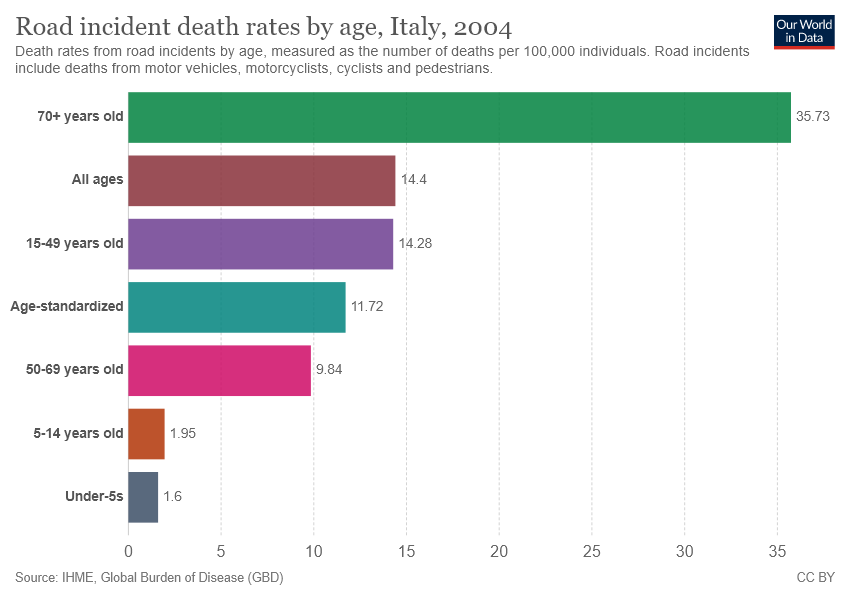Point out several critical features in this image. The sum of the average and median road incident death rates for all age groups is 24.5. The longest bar is twice as long as the shortest bar, based on the value. 